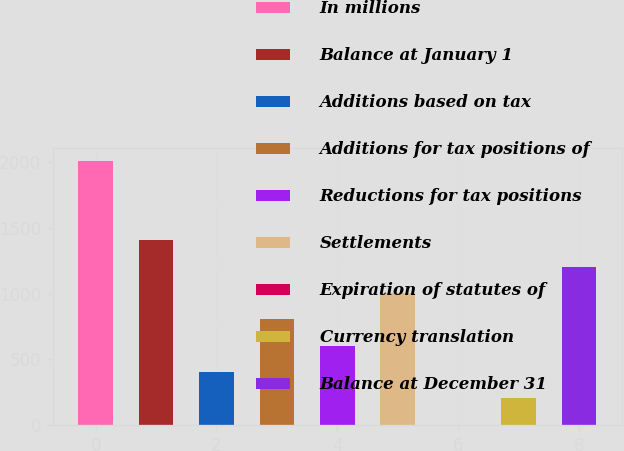<chart> <loc_0><loc_0><loc_500><loc_500><bar_chart><fcel>In millions<fcel>Balance at January 1<fcel>Additions based on tax<fcel>Additions for tax positions of<fcel>Reductions for tax positions<fcel>Settlements<fcel>Expiration of statutes of<fcel>Currency translation<fcel>Balance at December 31<nl><fcel>2009<fcel>1406.9<fcel>403.4<fcel>804.8<fcel>604.1<fcel>1005.5<fcel>2<fcel>202.7<fcel>1206.2<nl></chart> 